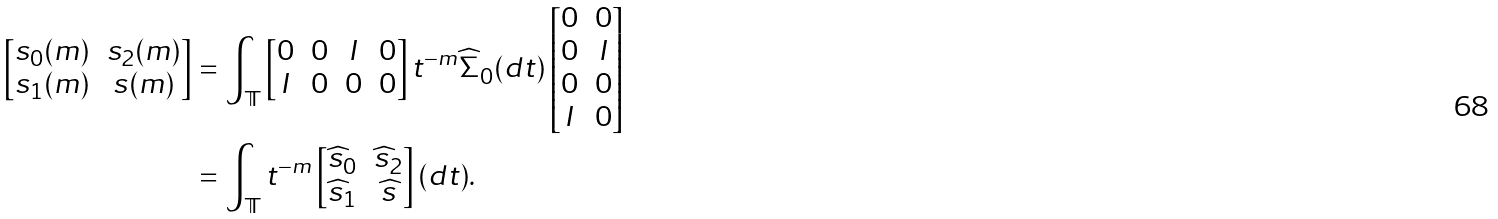Convert formula to latex. <formula><loc_0><loc_0><loc_500><loc_500>\begin{bmatrix} s _ { 0 } ( m ) & s _ { 2 } ( m ) \\ s _ { 1 } ( m ) & s ( m ) \end{bmatrix} & = \int _ { \mathbb { T } } \begin{bmatrix} 0 & 0 & I & 0 \\ I & 0 & 0 & 0 \end{bmatrix} t ^ { - m } \widehat { \Sigma } _ { 0 } ( d t ) \begin{bmatrix} 0 & 0 \\ 0 & I \\ 0 & 0 \\ I & 0 \end{bmatrix} \\ & = \int _ { \mathbb { T } } t ^ { - m } \begin{bmatrix} \widehat { s } _ { 0 } & \widehat { s } _ { 2 } \\ \widehat { s } _ { 1 } & \widehat { s } \end{bmatrix} ( d t ) .</formula> 